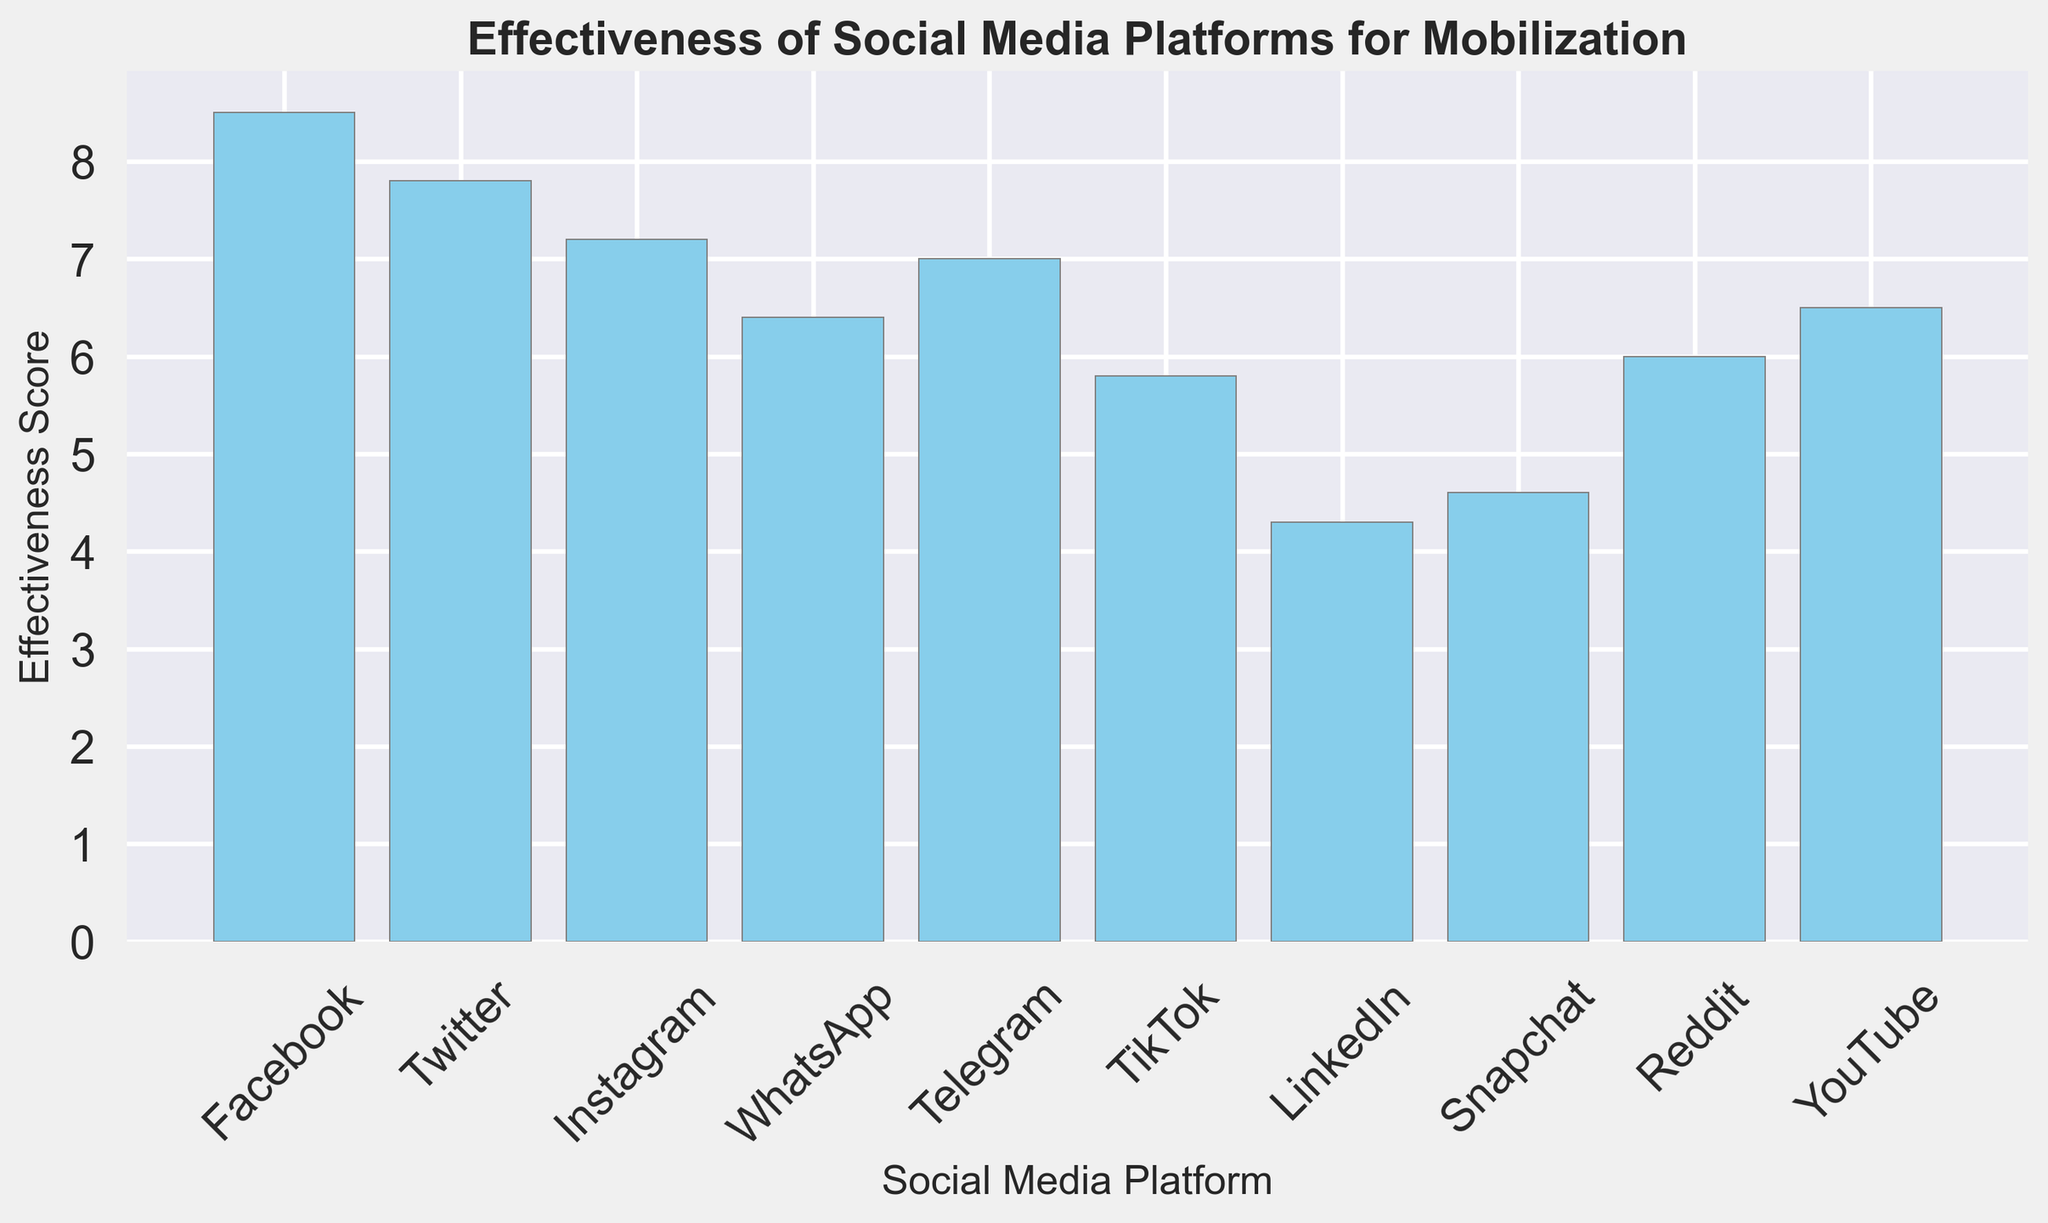Which social media platform has the highest effectiveness score? The platform with the highest bar represents the highest effectiveness score. By examining the figure, it's clear that Facebook has the tallest bar.
Answer: Facebook Which two platforms have the closest effectiveness scores? Looking at the bars, we can see that Telegram and Instagram have bars that are almost at the same height, indicating similar effectiveness scores.
Answer: Telegram and Instagram What is the difference in effectiveness scores between Twitter and LinkedIn? Referring to the heights of the bars, the effectiveness score for Twitter is 7.8 and for LinkedIn is 4.3. The difference is 7.8 - 4.3.
Answer: 3.5 How does the performance of WhatsApp compare to YouTube? By checking the bar heights, WhatsApp has a score of 6.4 and YouTube has a score of 6.5, indicating YouTube is slightly more effective.
Answer: YouTube is slightly more effective What is the average effectiveness score of Facebook, Twitter, and Instagram? Adding the effectiveness scores of Facebook (8.5), Twitter (7.8), and Instagram (7.2) and dividing by three: (8.5 + 7.8 + 7.2) / 3
Answer: 7.83 Which platform is the least effective for mobilization? The shortest bar indicates the least effectiveness. Here, LinkedIn has the shortest bar.
Answer: LinkedIn How many platforms have an effectiveness score above 7? By observing the heights of the bars and counting those above the 7 mark, the platforms are Facebook, Twitter, Instagram, and Telegram.
Answer: 4 What is the combined effectiveness score of TikTok and Snapchat? The effectiveness scores for TikTok and Snapchat are 5.8 and 4.6 respectively. Adding these together: 5.8 + 4.6
Answer: 10.4 If we exclude Facebook, which platform has the second-highest effectiveness score? Without considering Facebook, Twitter has the second-highest bar after Facebook.
Answer: Twitter What is the median effectiveness score of all platforms? Arranging the scores from lowest to highest (4.3, 4.6, 5.8, 6.0, 6.4, 6.5, 7.0, 7.2, 7.8, 8.5), and finding the middle value(s). The median score is between 6.4 (WhatsApp) and 6.5 (YouTube), thus the median is (6.4 + 6.5) / 2.
Answer: 6.45 